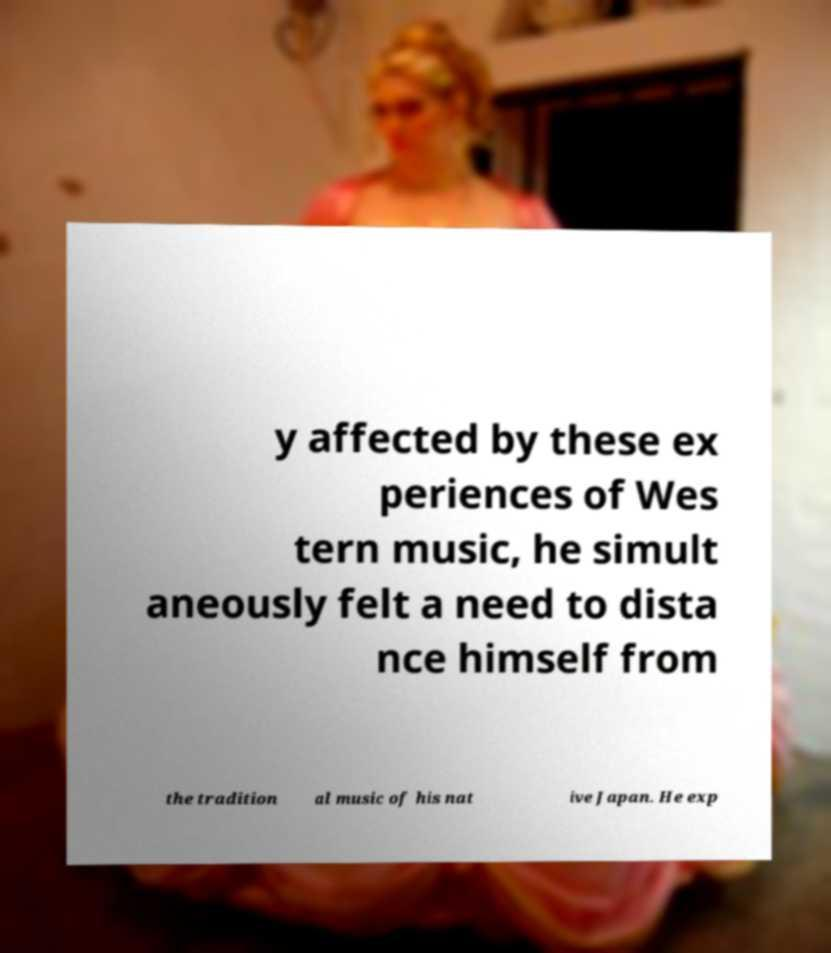Could you extract and type out the text from this image? y affected by these ex periences of Wes tern music, he simult aneously felt a need to dista nce himself from the tradition al music of his nat ive Japan. He exp 